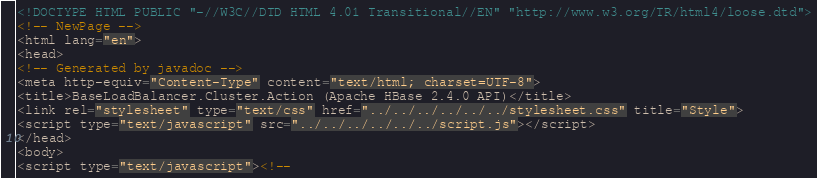<code> <loc_0><loc_0><loc_500><loc_500><_HTML_><!DOCTYPE HTML PUBLIC "-//W3C//DTD HTML 4.01 Transitional//EN" "http://www.w3.org/TR/html4/loose.dtd">
<!-- NewPage -->
<html lang="en">
<head>
<!-- Generated by javadoc -->
<meta http-equiv="Content-Type" content="text/html; charset=UTF-8">
<title>BaseLoadBalancer.Cluster.Action (Apache HBase 2.4.0 API)</title>
<link rel="stylesheet" type="text/css" href="../../../../../../stylesheet.css" title="Style">
<script type="text/javascript" src="../../../../../../script.js"></script>
</head>
<body>
<script type="text/javascript"><!--</code> 